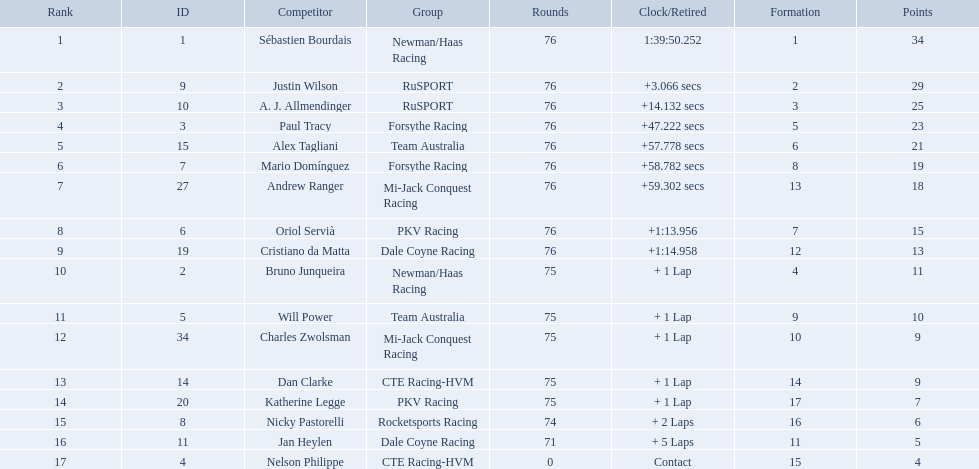What drivers took part in the 2006 tecate grand prix of monterrey? Sébastien Bourdais, Justin Wilson, A. J. Allmendinger, Paul Tracy, Alex Tagliani, Mario Domínguez, Andrew Ranger, Oriol Servià, Cristiano da Matta, Bruno Junqueira, Will Power, Charles Zwolsman, Dan Clarke, Katherine Legge, Nicky Pastorelli, Jan Heylen, Nelson Philippe. Which of those drivers scored the same amount of points as another driver? Charles Zwolsman, Dan Clarke. Who had the same amount of points as charles zwolsman? Dan Clarke. Which drivers completed all 76 laps? Sébastien Bourdais, Justin Wilson, A. J. Allmendinger, Paul Tracy, Alex Tagliani, Mario Domínguez, Andrew Ranger, Oriol Servià, Cristiano da Matta. Of these drivers, which ones finished less than a minute behind first place? Paul Tracy, Alex Tagliani, Mario Domínguez, Andrew Ranger. Of these drivers, which ones finished with a time less than 50 seconds behind first place? Justin Wilson, A. J. Allmendinger, Paul Tracy. Of these three drivers, who finished last? Paul Tracy. 